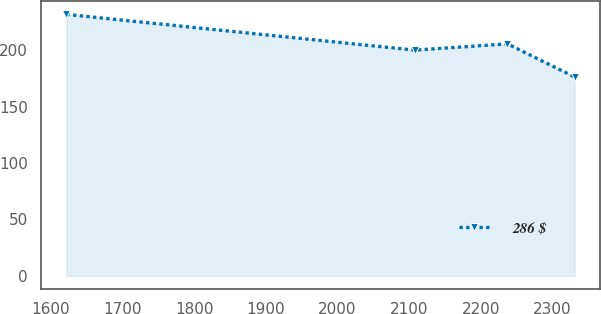Convert chart. <chart><loc_0><loc_0><loc_500><loc_500><line_chart><ecel><fcel>286 $<nl><fcel>1621.76<fcel>231.59<nl><fcel>2107.64<fcel>199.94<nl><fcel>2237.1<fcel>205.48<nl><fcel>2330.9<fcel>176.17<nl></chart> 